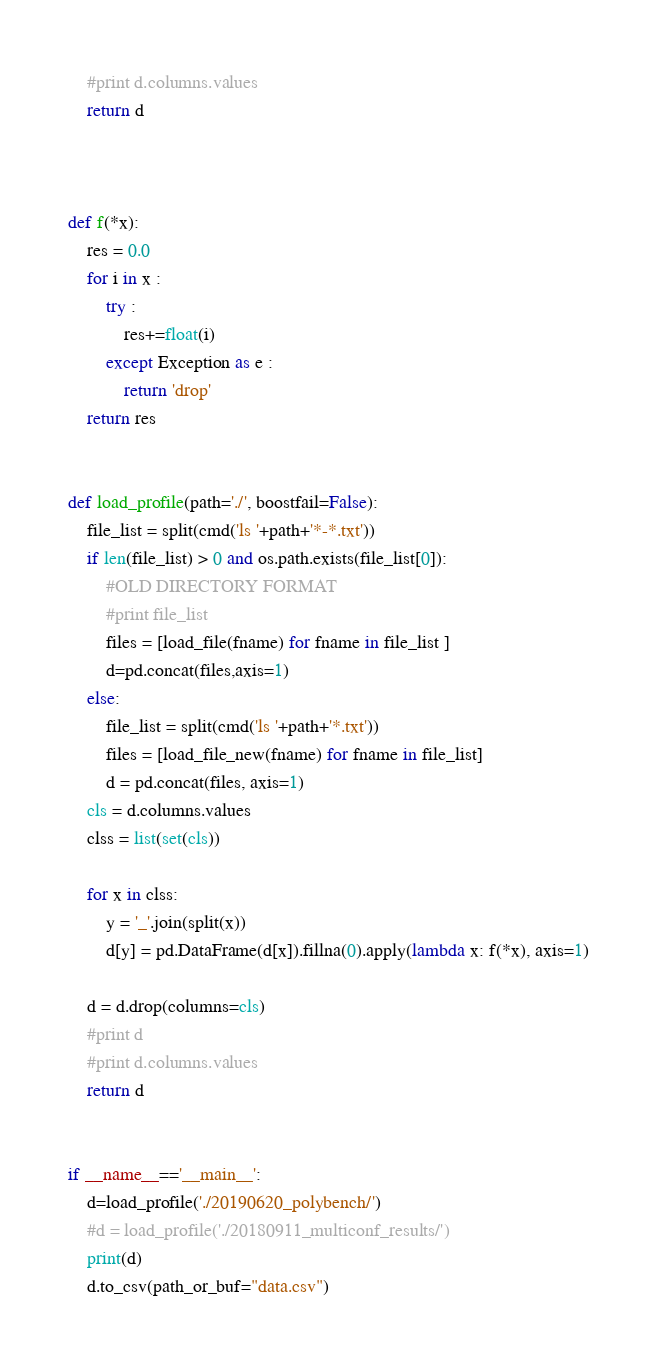Convert code to text. <code><loc_0><loc_0><loc_500><loc_500><_Python_>	#print d.columns.values
	return d
	


def f(*x):
	res = 0.0
	for i in x :
		try :
			res+=float(i)
		except Exception as e :
			return 'drop'
	return res


def load_profile(path='./', boostfail=False):
	file_list = split(cmd('ls '+path+'*-*.txt'))
	if len(file_list) > 0 and os.path.exists(file_list[0]):
		#OLD DIRECTORY FORMAT
		#print file_list
		files = [load_file(fname) for fname in file_list ]
		d=pd.concat(files,axis=1)
	else:
		file_list = split(cmd('ls '+path+'*.txt'))
		files = [load_file_new(fname) for fname in file_list]
		d = pd.concat(files, axis=1)
	cls = d.columns.values
	clss = list(set(cls))

	for x in clss:
		y = '_'.join(split(x))
		d[y] = pd.DataFrame(d[x]).fillna(0).apply(lambda x: f(*x), axis=1)

	d = d.drop(columns=cls)
	#print d
	#print d.columns.values
	return d


if __name__=='__main__':
	d=load_profile('./20190620_polybench/')
	#d = load_profile('./20180911_multiconf_results/')
	print(d)
	d.to_csv(path_or_buf="data.csv")
</code> 